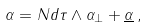<formula> <loc_0><loc_0><loc_500><loc_500>\alpha = N d \tau \wedge \alpha _ { \bot } + \underline { \alpha } \, ,</formula> 